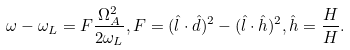<formula> <loc_0><loc_0><loc_500><loc_500>\omega - \omega _ { L } = F \frac { \Omega _ { A } ^ { 2 } } { 2 \omega _ { L } } , F = ( \hat { l } \cdot \hat { d } ) ^ { 2 } - ( \hat { l } \cdot \hat { h } ) ^ { 2 } , \hat { h } = \frac { H } { H } .</formula> 